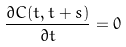<formula> <loc_0><loc_0><loc_500><loc_500>\frac { \partial C ( t , t + s ) } { \partial t } = 0</formula> 